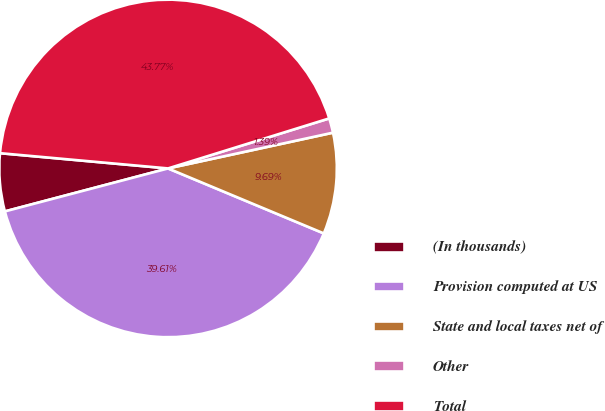Convert chart to OTSL. <chart><loc_0><loc_0><loc_500><loc_500><pie_chart><fcel>(In thousands)<fcel>Provision computed at US<fcel>State and local taxes net of<fcel>Other<fcel>Total<nl><fcel>5.54%<fcel>39.61%<fcel>9.69%<fcel>1.39%<fcel>43.77%<nl></chart> 